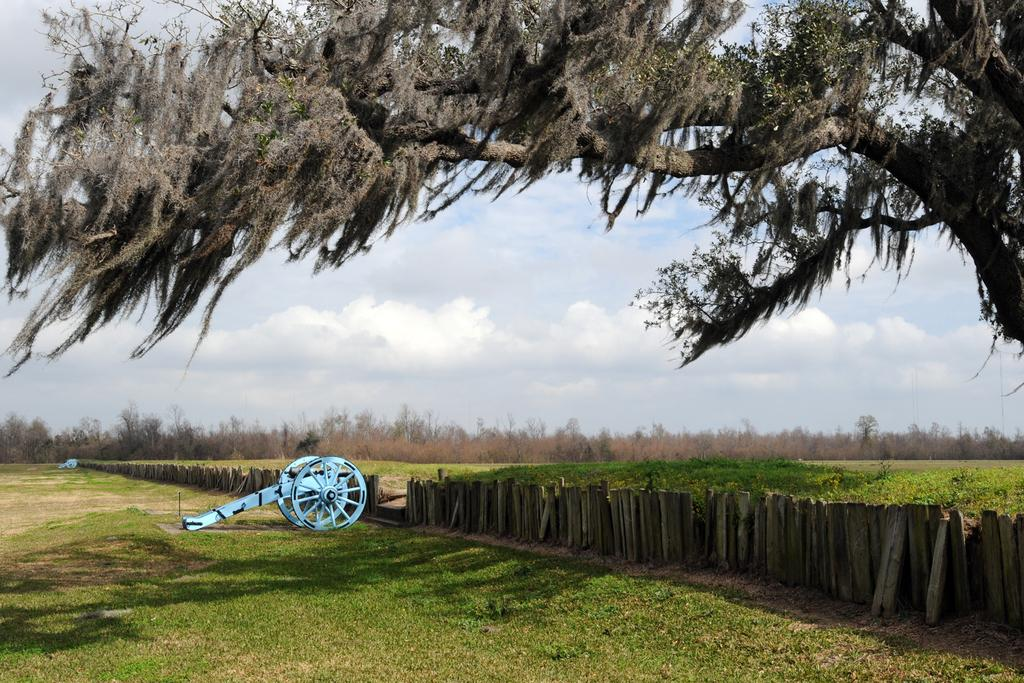What type of cart is in the image? There is a wooden cart in the image. Where is the wooden cart located? The wooden cart is on a grass field. What else can be seen in the image besides the wooden cart? There is a wooden fence and trees in the image. What is the ground covered with in the image? The ground is covered with grass. What type of polish is being applied to the hand in the image? There is no hand or polish present in the image. How many people are lifting the wooden cart in the image? There are no people visible in the image, and the wooden cart is stationary. 